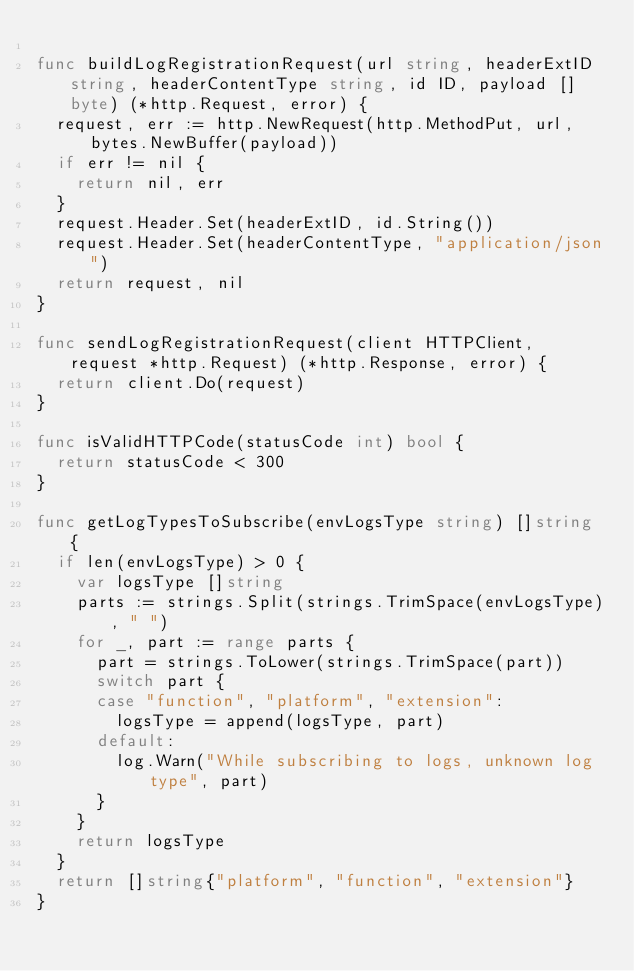<code> <loc_0><loc_0><loc_500><loc_500><_Go_>
func buildLogRegistrationRequest(url string, headerExtID string, headerContentType string, id ID, payload []byte) (*http.Request, error) {
	request, err := http.NewRequest(http.MethodPut, url, bytes.NewBuffer(payload))
	if err != nil {
		return nil, err
	}
	request.Header.Set(headerExtID, id.String())
	request.Header.Set(headerContentType, "application/json")
	return request, nil
}

func sendLogRegistrationRequest(client HTTPClient, request *http.Request) (*http.Response, error) {
	return client.Do(request)
}

func isValidHTTPCode(statusCode int) bool {
	return statusCode < 300
}

func getLogTypesToSubscribe(envLogsType string) []string {
	if len(envLogsType) > 0 {
		var logsType []string
		parts := strings.Split(strings.TrimSpace(envLogsType), " ")
		for _, part := range parts {
			part = strings.ToLower(strings.TrimSpace(part))
			switch part {
			case "function", "platform", "extension":
				logsType = append(logsType, part)
			default:
				log.Warn("While subscribing to logs, unknown log type", part)
			}
		}
		return logsType
	}
	return []string{"platform", "function", "extension"}
}
</code> 